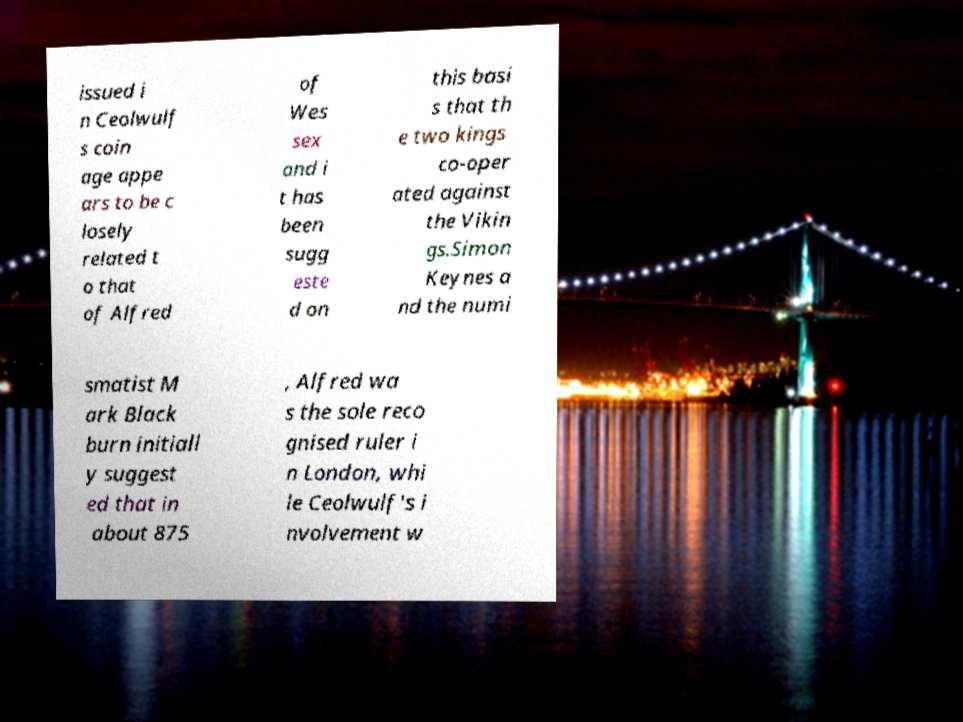There's text embedded in this image that I need extracted. Can you transcribe it verbatim? issued i n Ceolwulf s coin age appe ars to be c losely related t o that of Alfred of Wes sex and i t has been sugg este d on this basi s that th e two kings co-oper ated against the Vikin gs.Simon Keynes a nd the numi smatist M ark Black burn initiall y suggest ed that in about 875 , Alfred wa s the sole reco gnised ruler i n London, whi le Ceolwulf's i nvolvement w 